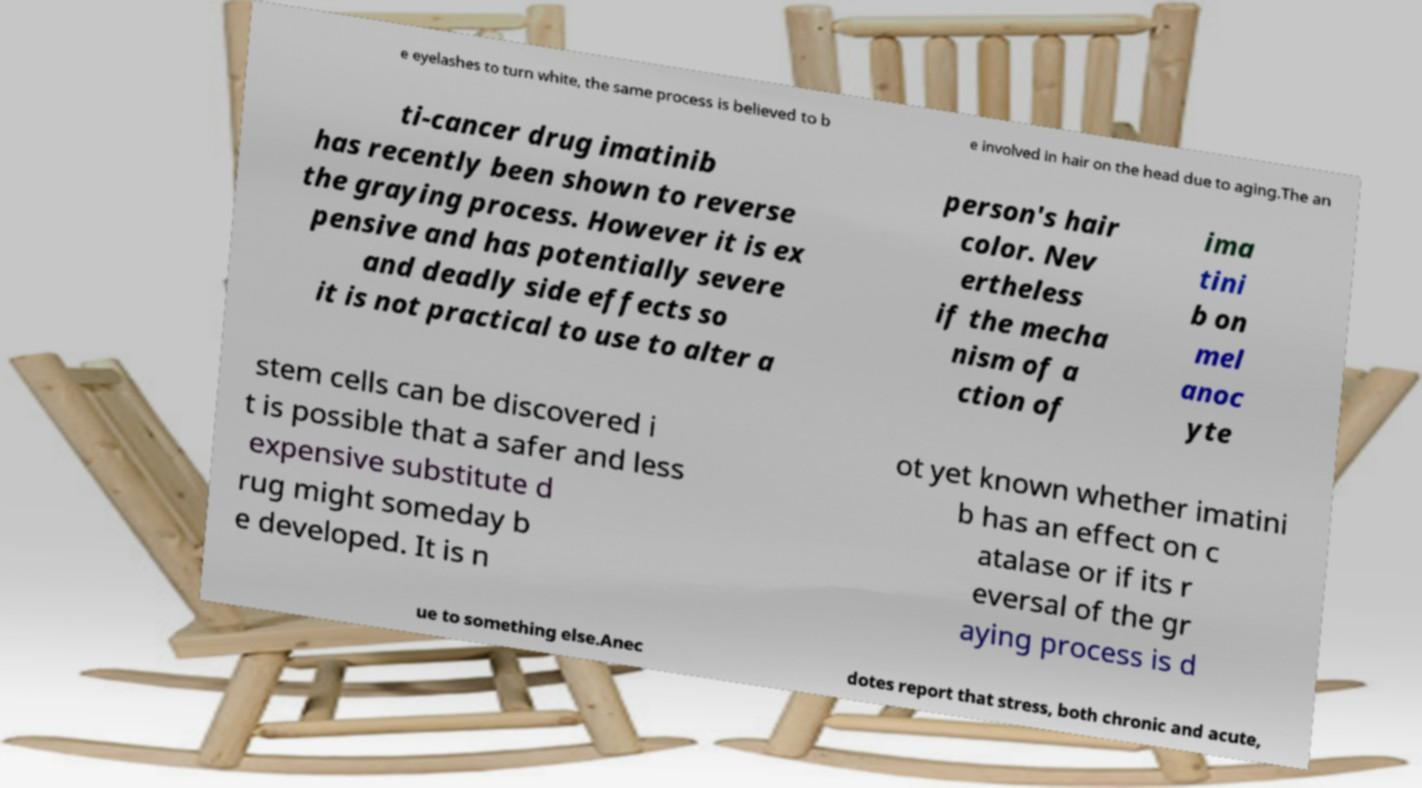What messages or text are displayed in this image? I need them in a readable, typed format. e eyelashes to turn white, the same process is believed to b e involved in hair on the head due to aging.The an ti-cancer drug imatinib has recently been shown to reverse the graying process. However it is ex pensive and has potentially severe and deadly side effects so it is not practical to use to alter a person's hair color. Nev ertheless if the mecha nism of a ction of ima tini b on mel anoc yte stem cells can be discovered i t is possible that a safer and less expensive substitute d rug might someday b e developed. It is n ot yet known whether imatini b has an effect on c atalase or if its r eversal of the gr aying process is d ue to something else.Anec dotes report that stress, both chronic and acute, 